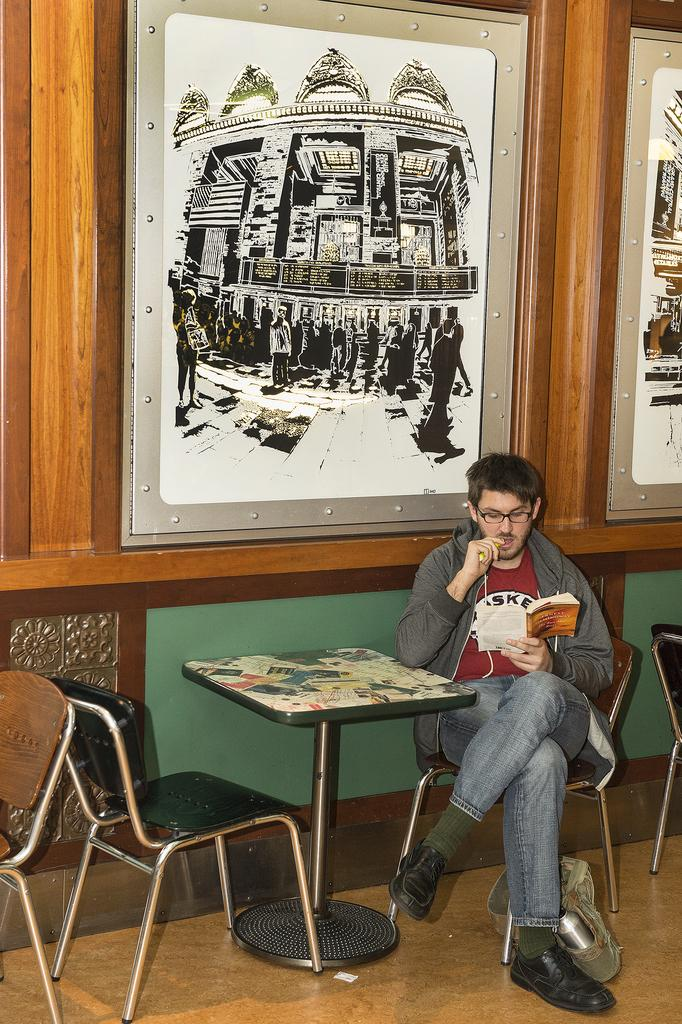What is the main subject of the image? There is a person in the image. What is the person doing in the image? The person is sitting on a chair and reading a book. Can you describe the environment around the person? There is a painting on the wall above the book. What type of pencil is the secretary using to take notes in the image? There is no secretary or pencil present in the image. The person in the image is reading a book, not taking notes. 